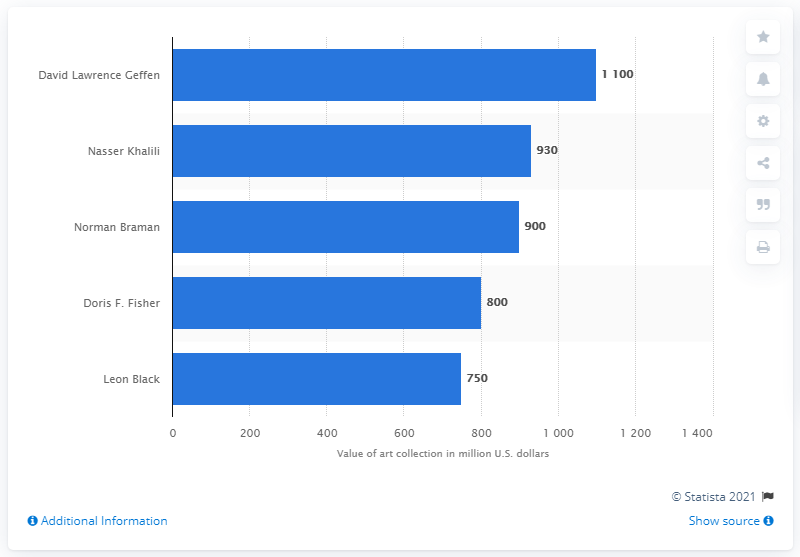Highlight a few significant elements in this photo. As of March 2014, David Lawrence Geffen was recognized as the world's leading art collector. David Lawrence Geffen's collection was worth an estimated 1100.... 